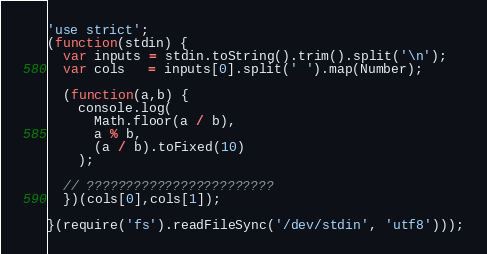<code> <loc_0><loc_0><loc_500><loc_500><_JavaScript_>'use strict';
(function(stdin) {
  var inputs = stdin.toString().trim().split('\n');
  var cols   = inputs[0].split(' ').map(Number);

  (function(a,b) {
    console.log(
      Math.floor(a / b),
      a % b,
      (a / b).toFixed(10)
    );

  // ????????????????????????
  })(cols[0],cols[1]);

}(require('fs').readFileSync('/dev/stdin', 'utf8')));</code> 